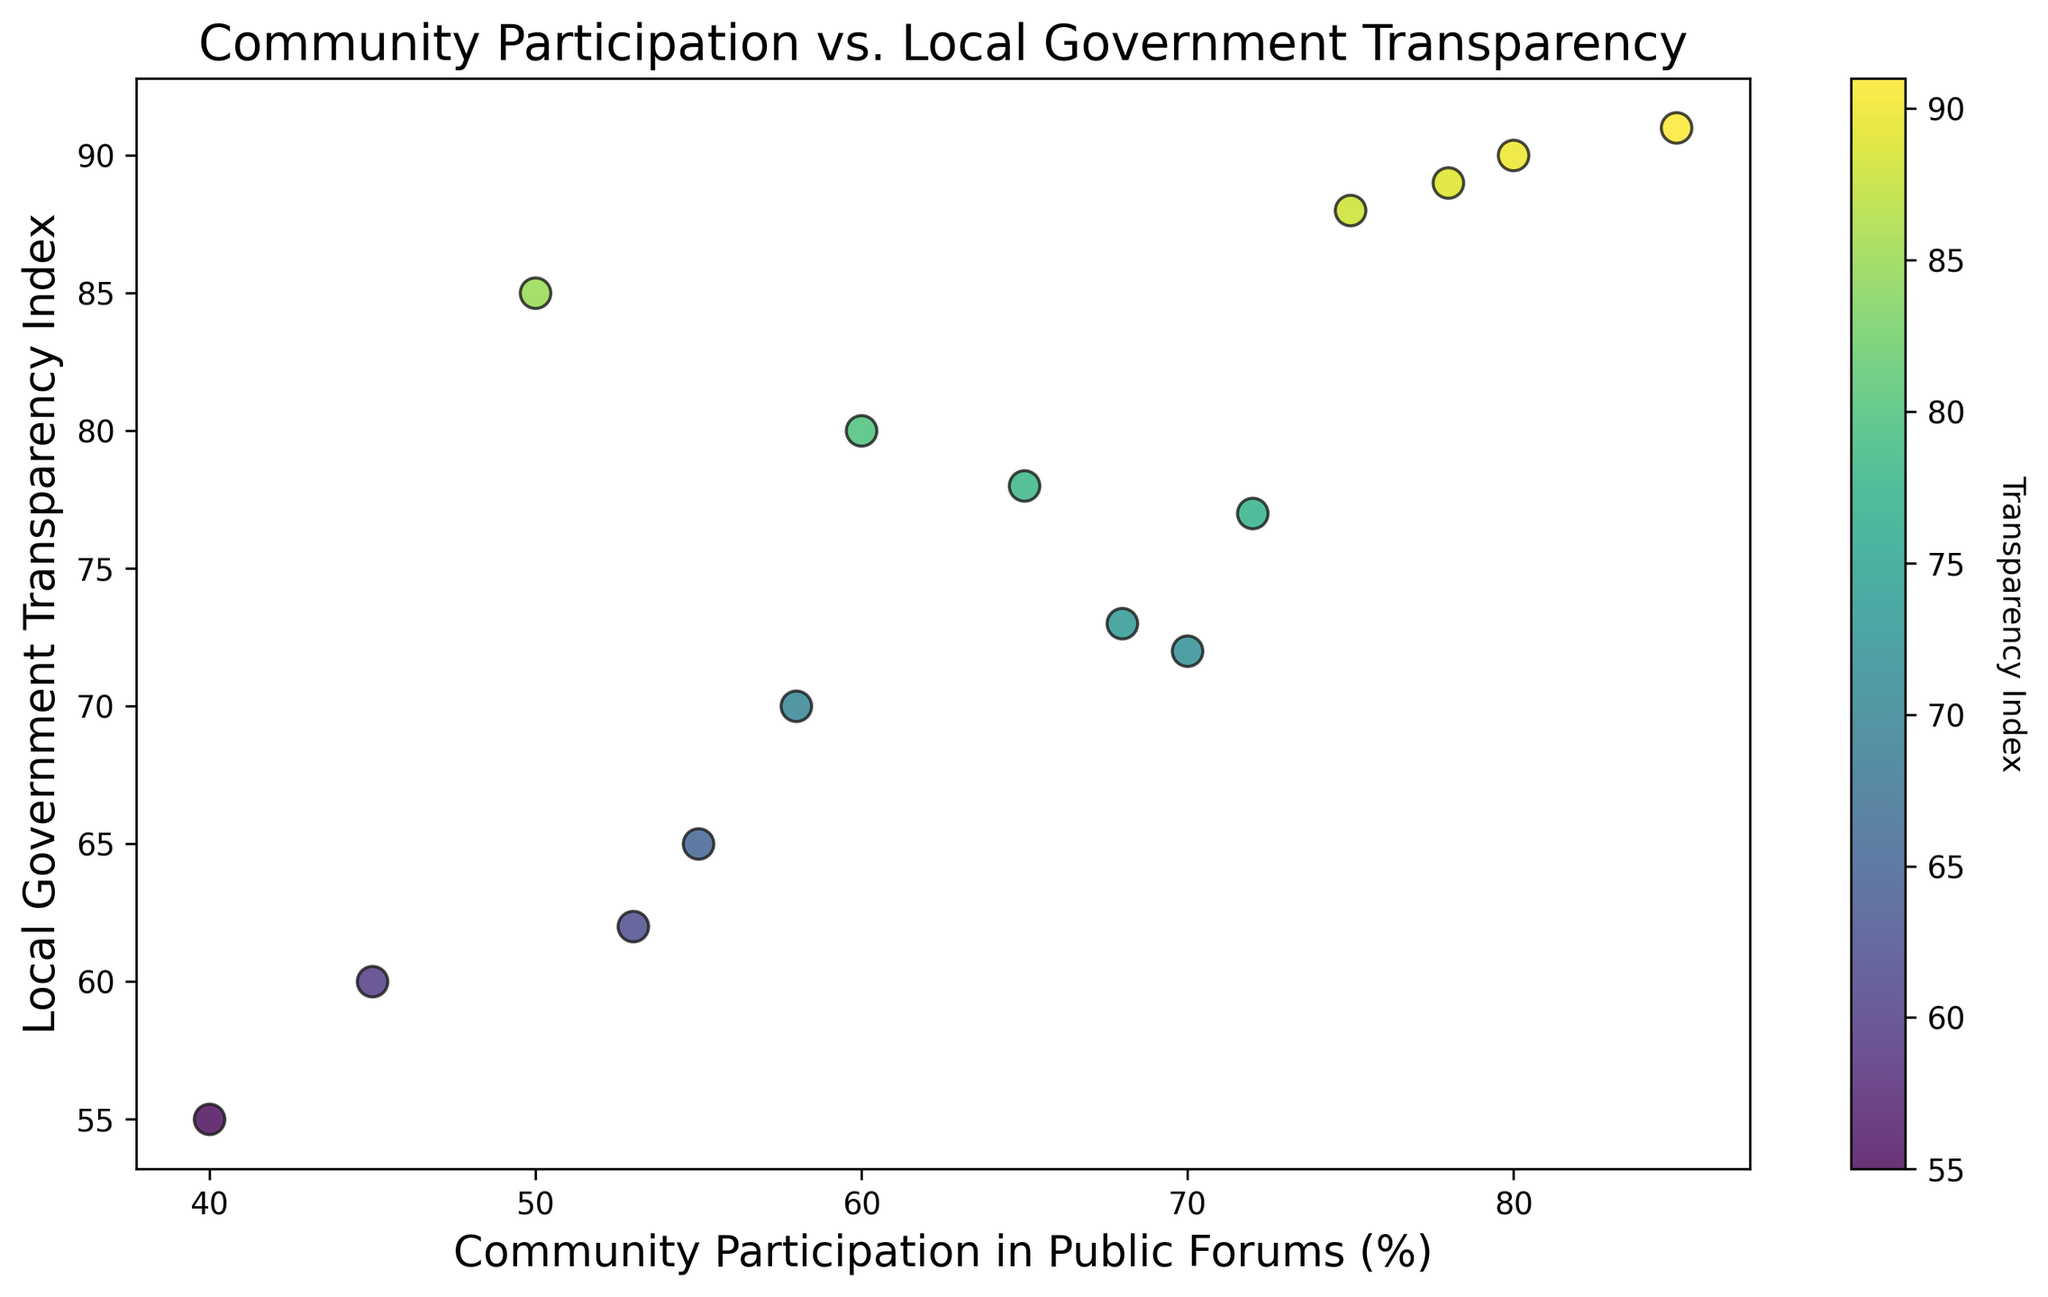What's the average Local Government Transparency Index for cities with more than 70% Community Participation in Public Forums? First, identify the cities with more than 70% community participation: City C (90), City G (88), City I (91), and City O (89). Then calculate the average: (90 + 88 + 91 + 89) / 4 = 89.5
Answer: 89.5 Which city has the highest Community Participation in Public Forums percentage, and what is its Local Government Transparency Index value? The city with the highest community participation is City I, with 85% participation. The Local Government Transparency Index for City I is 91.
Answer: City I, 91 Is there a noticeable trend between Community Participation in Public Forums and Local Government Transparency Index? Visually, there appears to be a positive correlation where higher community participation often correlates with higher local government transparency. This is observed through the general upward trend in the scatter plot.
Answer: Positive correlation How many cities have a Local Government Transparency Index greater than or equal to 80? Count the cities with a transparency index of 80 or more: City B (85), City C (90), City G (88), City H (80), City I (91), and City O (89). There are 6 cities.
Answer: 6 What is the range of Community Participation in Public Forums percentages shown in the plot? The lowest value for community participation is 40% (City J) and the highest is 85% (City I). The range is calculated as 85 - 40 = 45%.
Answer: 45% Which city has the lowest Local Government Transparency Index, and what is its Community Participation in Public Forums percentage? The city with the lowest transparency index is City J at 55. The community participation percentage for City J is 40%.
Answer: City J, 40% Among the cities with a Local Government Transparency Index less than 70, what is the highest Community Participation in Public Forums percentage? Identify cities with a transparency index less than 70: City D (65), City F (60), City J (55), and City M (62). The highest community participation among these cities is City D with 55%.
Answer: 55% Do any cities have a perfect overlap of points on the scatter plot according to the given data? No cities have a perfect overlap because all community participation percentages and transparency indices are unique for each city.
Answer: No 